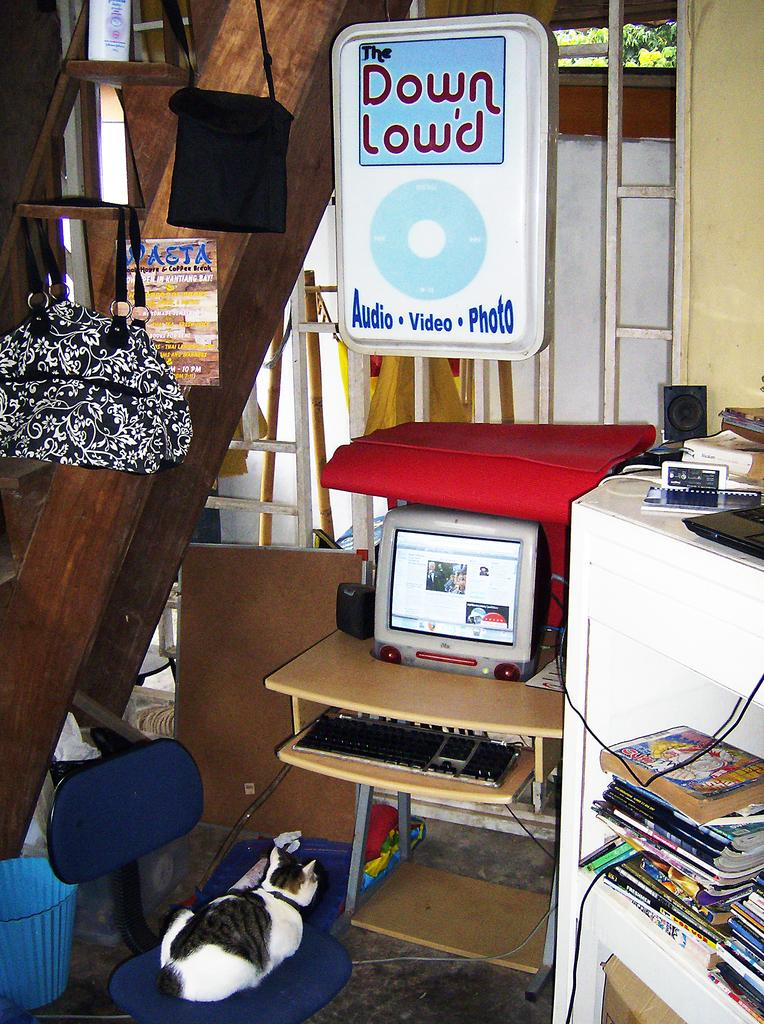What animal is sitting on a chair in the image? There is a cat on a chair in the image. What electronic device is on the table in the image? There is a monitor on a table in the image. What is used for typing on the monitor in the image? There is a keyboard on the table in the image. What is used for producing sound in the image? There is a speaker on the table in the image. What type of storage is present in the image? There are books in a rack in the image, and there are items on the rack as well. What are the two hanging objects in the image? There are two bags hanging in the image. Is there a water current visible in the image? No, there is no water or current present in the image. Can you see a snail crawling on the cat in the image? No, there is no snail visible in the image. 